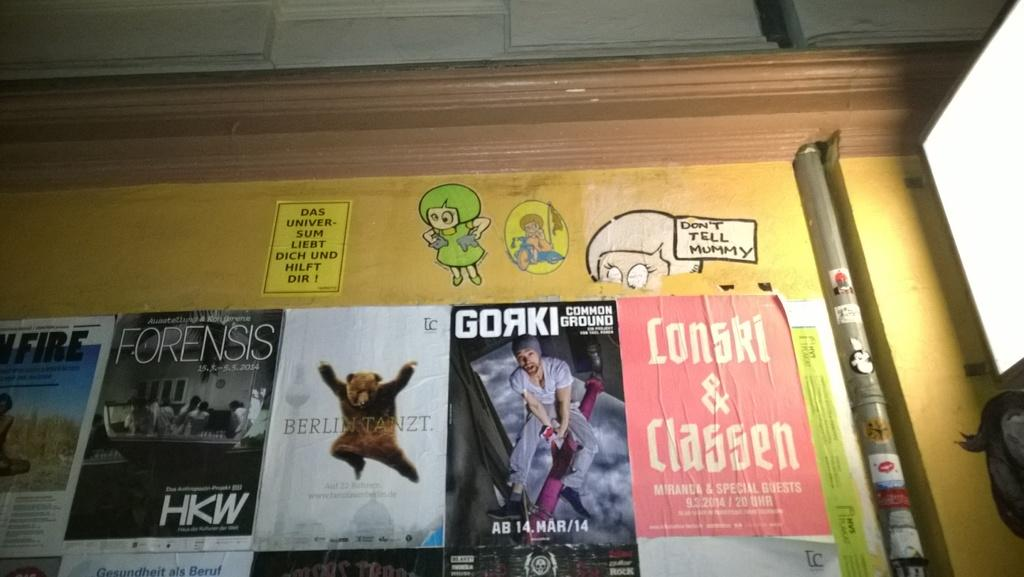<image>
Give a short and clear explanation of the subsequent image. A collection of magazine covers are posted to a billboard along with a message that says don't tell mummy. 